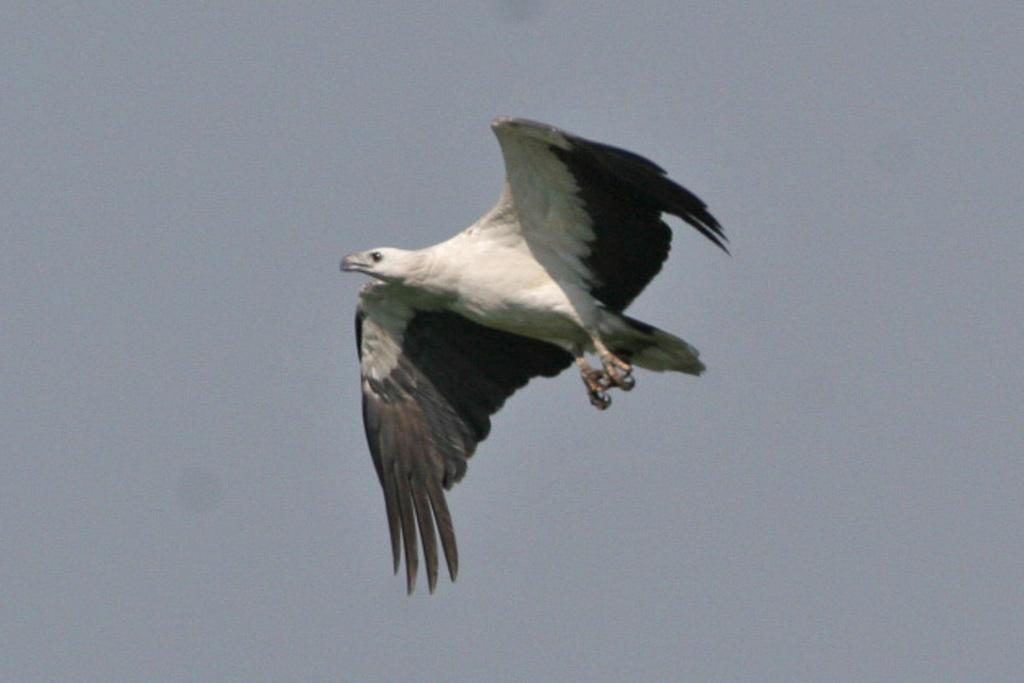What type of animal can be seen in the image? There is a bird in the image. What is the bird doing in the image? The bird is flying in the air. What can be seen in the background of the image? The sky is visible in the background of the image. What type of game is the bird playing in the image? There is no game being played in the image; the bird is simply flying in the air. 